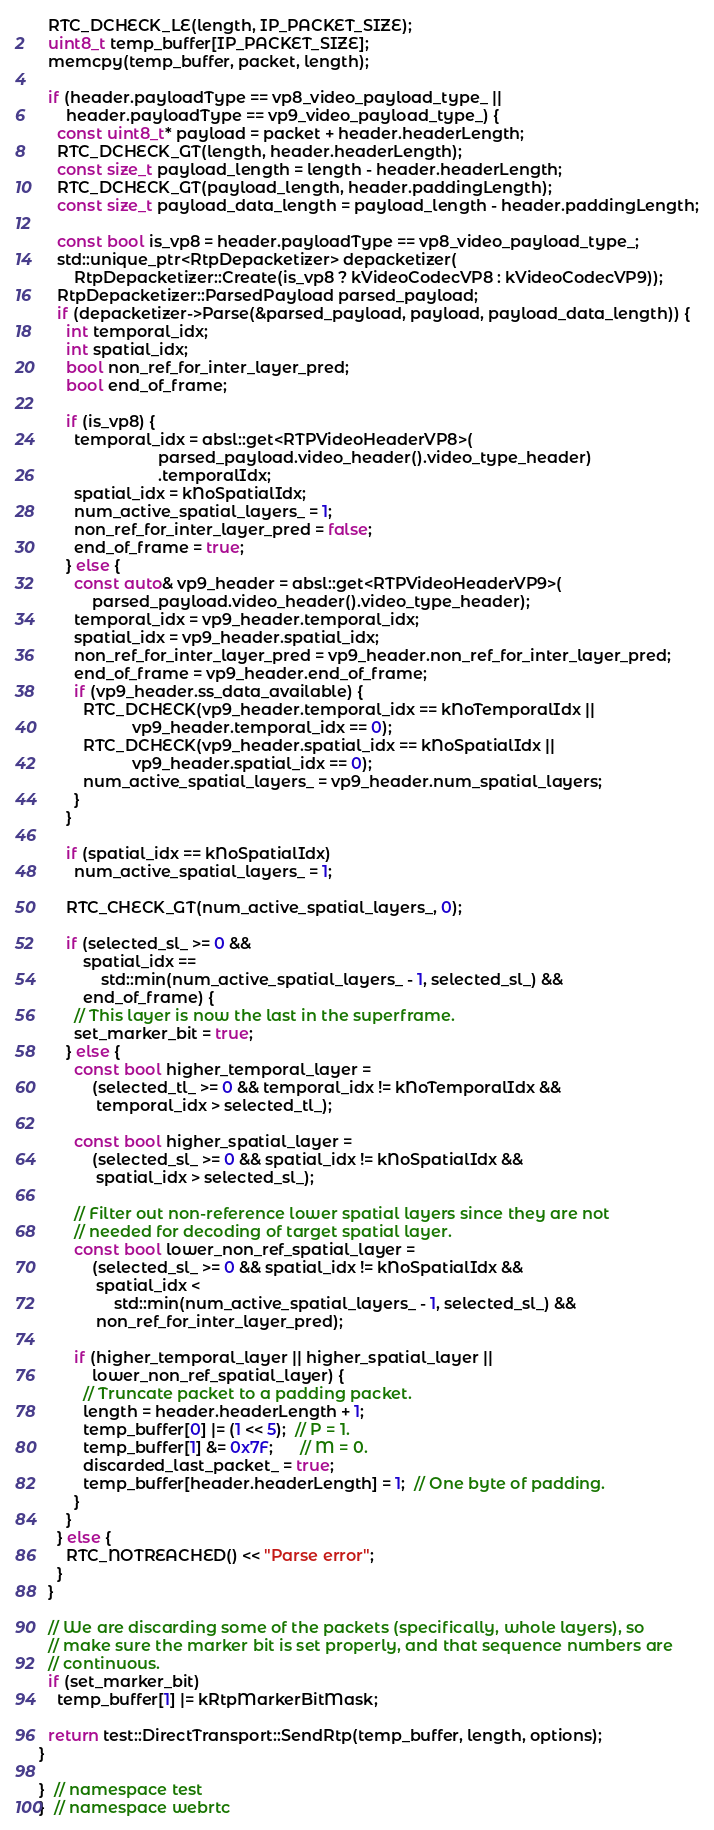Convert code to text. <code><loc_0><loc_0><loc_500><loc_500><_C++_>  RTC_DCHECK_LE(length, IP_PACKET_SIZE);
  uint8_t temp_buffer[IP_PACKET_SIZE];
  memcpy(temp_buffer, packet, length);

  if (header.payloadType == vp8_video_payload_type_ ||
      header.payloadType == vp9_video_payload_type_) {
    const uint8_t* payload = packet + header.headerLength;
    RTC_DCHECK_GT(length, header.headerLength);
    const size_t payload_length = length - header.headerLength;
    RTC_DCHECK_GT(payload_length, header.paddingLength);
    const size_t payload_data_length = payload_length - header.paddingLength;

    const bool is_vp8 = header.payloadType == vp8_video_payload_type_;
    std::unique_ptr<RtpDepacketizer> depacketizer(
        RtpDepacketizer::Create(is_vp8 ? kVideoCodecVP8 : kVideoCodecVP9));
    RtpDepacketizer::ParsedPayload parsed_payload;
    if (depacketizer->Parse(&parsed_payload, payload, payload_data_length)) {
      int temporal_idx;
      int spatial_idx;
      bool non_ref_for_inter_layer_pred;
      bool end_of_frame;

      if (is_vp8) {
        temporal_idx = absl::get<RTPVideoHeaderVP8>(
                           parsed_payload.video_header().video_type_header)
                           .temporalIdx;
        spatial_idx = kNoSpatialIdx;
        num_active_spatial_layers_ = 1;
        non_ref_for_inter_layer_pred = false;
        end_of_frame = true;
      } else {
        const auto& vp9_header = absl::get<RTPVideoHeaderVP9>(
            parsed_payload.video_header().video_type_header);
        temporal_idx = vp9_header.temporal_idx;
        spatial_idx = vp9_header.spatial_idx;
        non_ref_for_inter_layer_pred = vp9_header.non_ref_for_inter_layer_pred;
        end_of_frame = vp9_header.end_of_frame;
        if (vp9_header.ss_data_available) {
          RTC_DCHECK(vp9_header.temporal_idx == kNoTemporalIdx ||
                     vp9_header.temporal_idx == 0);
          RTC_DCHECK(vp9_header.spatial_idx == kNoSpatialIdx ||
                     vp9_header.spatial_idx == 0);
          num_active_spatial_layers_ = vp9_header.num_spatial_layers;
        }
      }

      if (spatial_idx == kNoSpatialIdx)
        num_active_spatial_layers_ = 1;

      RTC_CHECK_GT(num_active_spatial_layers_, 0);

      if (selected_sl_ >= 0 &&
          spatial_idx ==
              std::min(num_active_spatial_layers_ - 1, selected_sl_) &&
          end_of_frame) {
        // This layer is now the last in the superframe.
        set_marker_bit = true;
      } else {
        const bool higher_temporal_layer =
            (selected_tl_ >= 0 && temporal_idx != kNoTemporalIdx &&
             temporal_idx > selected_tl_);

        const bool higher_spatial_layer =
            (selected_sl_ >= 0 && spatial_idx != kNoSpatialIdx &&
             spatial_idx > selected_sl_);

        // Filter out non-reference lower spatial layers since they are not
        // needed for decoding of target spatial layer.
        const bool lower_non_ref_spatial_layer =
            (selected_sl_ >= 0 && spatial_idx != kNoSpatialIdx &&
             spatial_idx <
                 std::min(num_active_spatial_layers_ - 1, selected_sl_) &&
             non_ref_for_inter_layer_pred);

        if (higher_temporal_layer || higher_spatial_layer ||
            lower_non_ref_spatial_layer) {
          // Truncate packet to a padding packet.
          length = header.headerLength + 1;
          temp_buffer[0] |= (1 << 5);  // P = 1.
          temp_buffer[1] &= 0x7F;      // M = 0.
          discarded_last_packet_ = true;
          temp_buffer[header.headerLength] = 1;  // One byte of padding.
        }
      }
    } else {
      RTC_NOTREACHED() << "Parse error";
    }
  }

  // We are discarding some of the packets (specifically, whole layers), so
  // make sure the marker bit is set properly, and that sequence numbers are
  // continuous.
  if (set_marker_bit)
    temp_buffer[1] |= kRtpMarkerBitMask;

  return test::DirectTransport::SendRtp(temp_buffer, length, options);
}

}  // namespace test
}  // namespace webrtc
</code> 